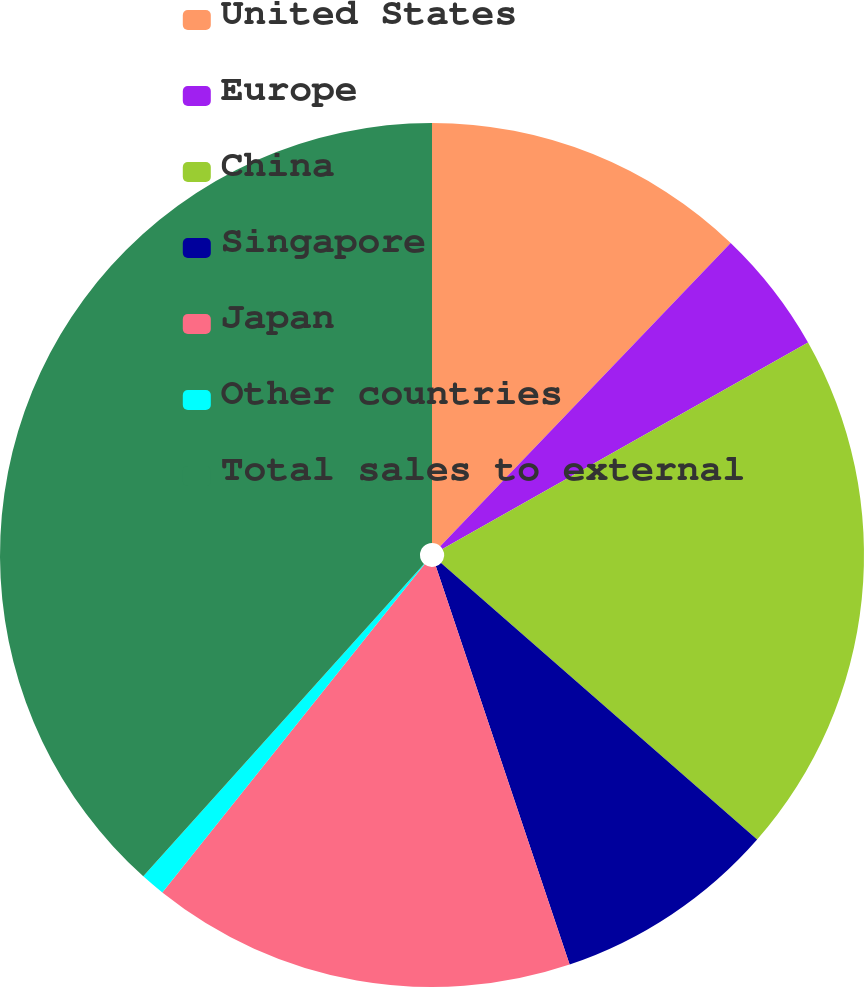Convert chart to OTSL. <chart><loc_0><loc_0><loc_500><loc_500><pie_chart><fcel>United States<fcel>Europe<fcel>China<fcel>Singapore<fcel>Japan<fcel>Other countries<fcel>Total sales to external<nl><fcel>12.15%<fcel>4.66%<fcel>19.63%<fcel>8.4%<fcel>15.89%<fcel>0.92%<fcel>38.35%<nl></chart> 